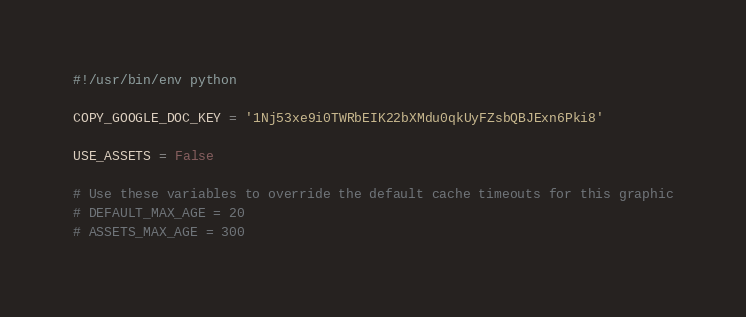<code> <loc_0><loc_0><loc_500><loc_500><_Python_>#!/usr/bin/env python

COPY_GOOGLE_DOC_KEY = '1Nj53xe9i0TWRbEIK22bXMdu0qkUyFZsbQBJExn6Pki8'

USE_ASSETS = False

# Use these variables to override the default cache timeouts for this graphic
# DEFAULT_MAX_AGE = 20
# ASSETS_MAX_AGE = 300
</code> 